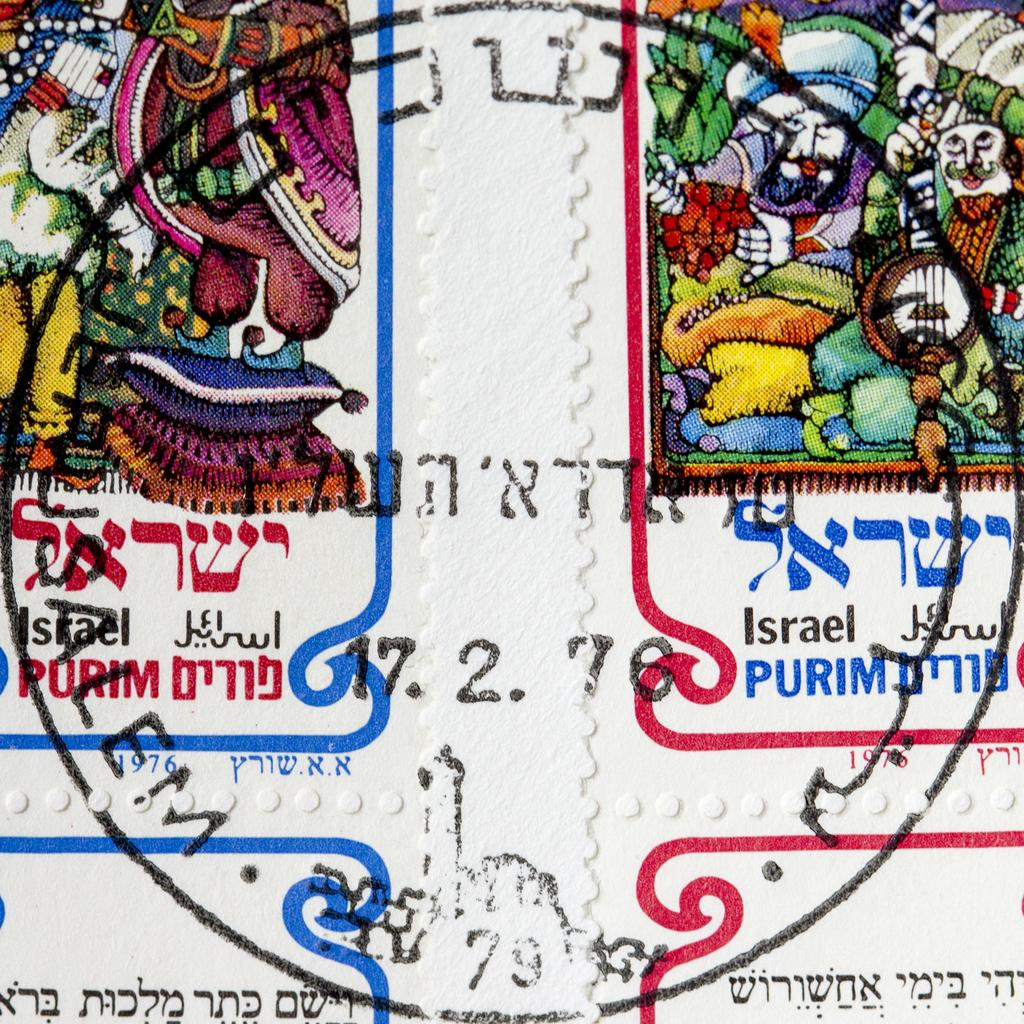What is the main object in the image? There is a stamp paper in the image. What can be seen on the stamp paper? The stamp paper has a design on it. What type of hair is visible on the stamp paper? There is no hair visible on the stamp paper; it is a piece of paper with a design on it. 